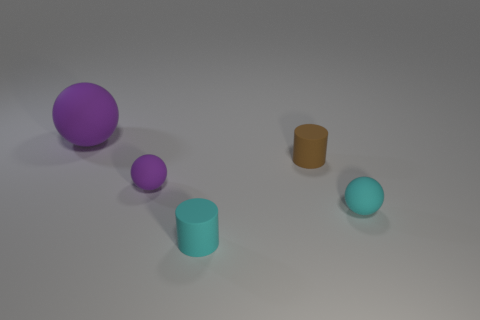Is there anything else that is the same size as the cyan matte ball?
Your response must be concise. Yes. There is a brown matte object that is right of the cyan cylinder; is its size the same as the small purple object?
Your answer should be compact. Yes. How many cyan things are small matte cylinders or small rubber balls?
Keep it short and to the point. 2. What material is the small object that is left of the tiny cyan cylinder?
Offer a very short reply. Rubber. There is a tiny rubber cylinder that is behind the tiny cyan matte cylinder; what number of small cyan matte balls are in front of it?
Provide a succinct answer. 1. How many other big objects are the same shape as the brown thing?
Provide a short and direct response. 0. What number of tiny cyan objects are there?
Offer a terse response. 2. The tiny ball right of the tiny purple matte ball is what color?
Offer a terse response. Cyan. There is a tiny ball that is to the right of the tiny rubber cylinder in front of the cyan rubber ball; what is its color?
Keep it short and to the point. Cyan. There is a matte cylinder that is the same size as the brown thing; what is its color?
Your response must be concise. Cyan. 